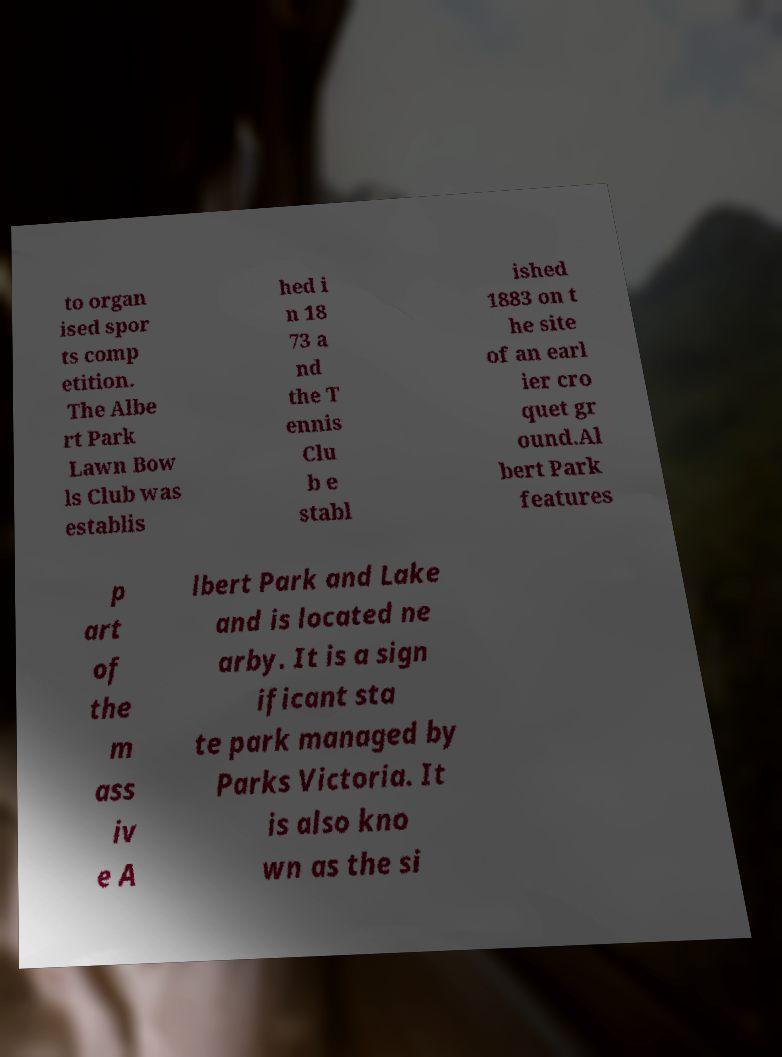What messages or text are displayed in this image? I need them in a readable, typed format. to organ ised spor ts comp etition. The Albe rt Park Lawn Bow ls Club was establis hed i n 18 73 a nd the T ennis Clu b e stabl ished 1883 on t he site of an earl ier cro quet gr ound.Al bert Park features p art of the m ass iv e A lbert Park and Lake and is located ne arby. It is a sign ificant sta te park managed by Parks Victoria. It is also kno wn as the si 